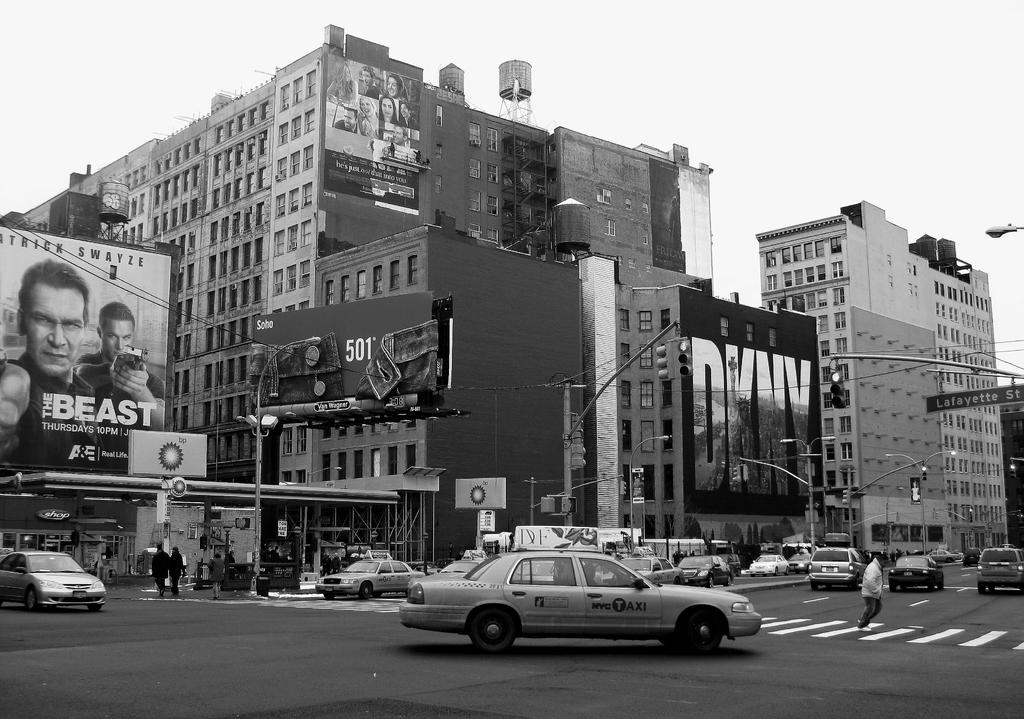<image>
Share a concise interpretation of the image provided. The billboard advertises a movie called The Beast with Swayze starring in it. 